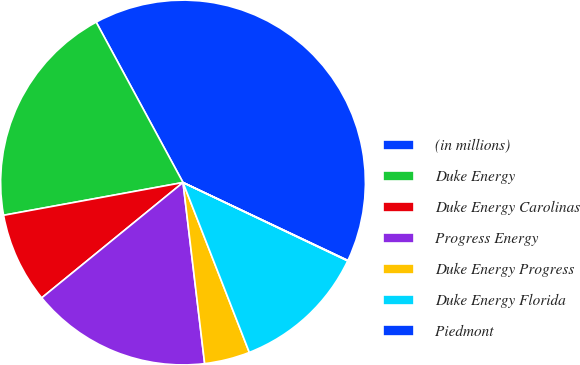Convert chart to OTSL. <chart><loc_0><loc_0><loc_500><loc_500><pie_chart><fcel>(in millions)<fcel>Duke Energy<fcel>Duke Energy Carolinas<fcel>Progress Energy<fcel>Duke Energy Progress<fcel>Duke Energy Florida<fcel>Piedmont<nl><fcel>39.93%<fcel>19.98%<fcel>8.02%<fcel>16.0%<fcel>4.03%<fcel>12.01%<fcel>0.04%<nl></chart> 